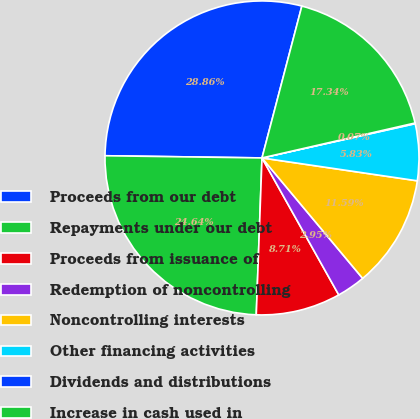Convert chart to OTSL. <chart><loc_0><loc_0><loc_500><loc_500><pie_chart><fcel>Proceeds from our debt<fcel>Repayments under our debt<fcel>Proceeds from issuance of<fcel>Redemption of noncontrolling<fcel>Noncontrolling interests<fcel>Other financing activities<fcel>Dividends and distributions<fcel>Increase in cash used in<nl><fcel>28.86%<fcel>24.64%<fcel>8.71%<fcel>2.95%<fcel>11.59%<fcel>5.83%<fcel>0.07%<fcel>17.34%<nl></chart> 